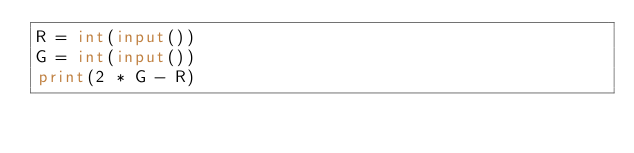<code> <loc_0><loc_0><loc_500><loc_500><_Python_>R = int(input())
G = int(input())
print(2 * G - R)
</code> 